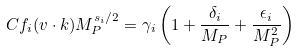<formula> <loc_0><loc_0><loc_500><loc_500>C f _ { i } ( v \cdot k ) M _ { P } ^ { s _ { i } / 2 } = \gamma _ { i } \left ( 1 + \frac { \delta _ { i } } { M _ { P } } + \frac { \epsilon _ { i } } { M ^ { 2 } _ { P } } \right ) \</formula> 